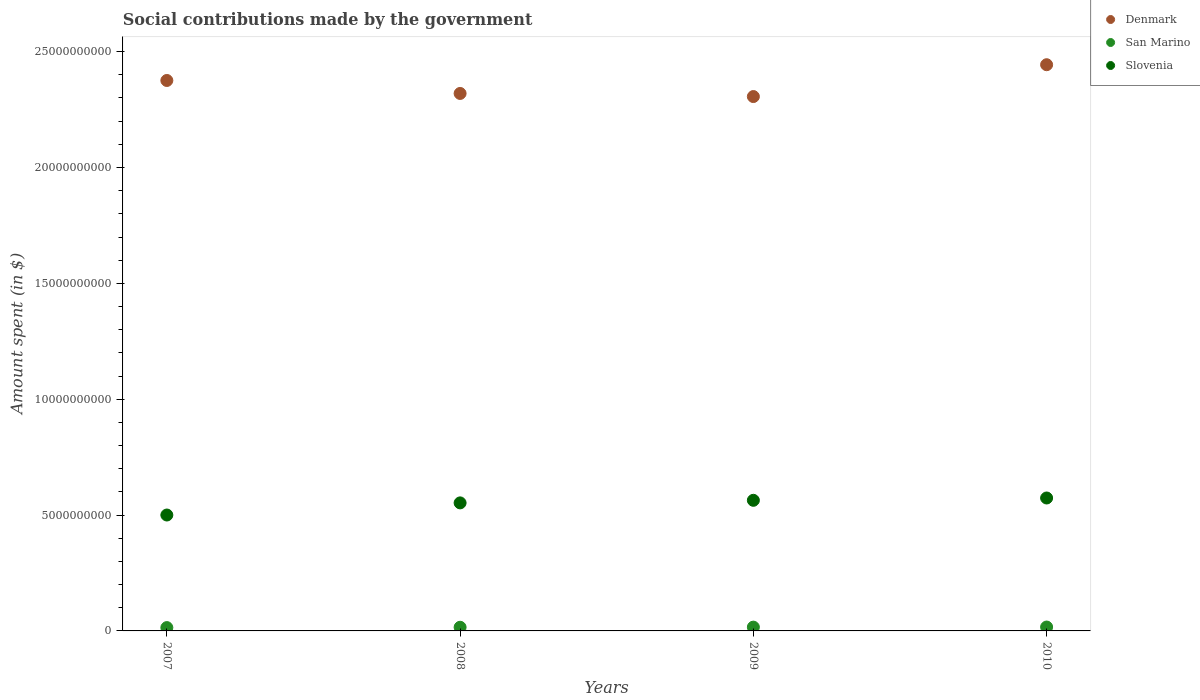What is the amount spent on social contributions in Slovenia in 2007?
Provide a succinct answer. 5.00e+09. Across all years, what is the maximum amount spent on social contributions in Denmark?
Give a very brief answer. 2.44e+1. Across all years, what is the minimum amount spent on social contributions in Slovenia?
Ensure brevity in your answer.  5.00e+09. In which year was the amount spent on social contributions in Denmark maximum?
Keep it short and to the point. 2010. In which year was the amount spent on social contributions in San Marino minimum?
Your response must be concise. 2007. What is the total amount spent on social contributions in Slovenia in the graph?
Give a very brief answer. 2.19e+1. What is the difference between the amount spent on social contributions in Denmark in 2009 and that in 2010?
Make the answer very short. -1.37e+09. What is the difference between the amount spent on social contributions in Denmark in 2008 and the amount spent on social contributions in San Marino in 2010?
Give a very brief answer. 2.30e+1. What is the average amount spent on social contributions in Denmark per year?
Give a very brief answer. 2.36e+1. In the year 2007, what is the difference between the amount spent on social contributions in Slovenia and amount spent on social contributions in San Marino?
Offer a terse response. 4.86e+09. In how many years, is the amount spent on social contributions in Slovenia greater than 1000000000 $?
Keep it short and to the point. 4. What is the ratio of the amount spent on social contributions in Denmark in 2009 to that in 2010?
Give a very brief answer. 0.94. Is the amount spent on social contributions in San Marino in 2008 less than that in 2010?
Your answer should be compact. Yes. Is the difference between the amount spent on social contributions in Slovenia in 2007 and 2010 greater than the difference between the amount spent on social contributions in San Marino in 2007 and 2010?
Give a very brief answer. No. What is the difference between the highest and the second highest amount spent on social contributions in Denmark?
Offer a terse response. 6.80e+08. What is the difference between the highest and the lowest amount spent on social contributions in Denmark?
Give a very brief answer. 1.37e+09. In how many years, is the amount spent on social contributions in Slovenia greater than the average amount spent on social contributions in Slovenia taken over all years?
Offer a terse response. 3. Is it the case that in every year, the sum of the amount spent on social contributions in Denmark and amount spent on social contributions in Slovenia  is greater than the amount spent on social contributions in San Marino?
Offer a terse response. Yes. Is the amount spent on social contributions in San Marino strictly less than the amount spent on social contributions in Denmark over the years?
Make the answer very short. Yes. What is the difference between two consecutive major ticks on the Y-axis?
Your answer should be compact. 5.00e+09. Are the values on the major ticks of Y-axis written in scientific E-notation?
Give a very brief answer. No. Does the graph contain any zero values?
Make the answer very short. No. Does the graph contain grids?
Offer a terse response. No. Where does the legend appear in the graph?
Your response must be concise. Top right. How many legend labels are there?
Offer a very short reply. 3. What is the title of the graph?
Offer a very short reply. Social contributions made by the government. Does "Denmark" appear as one of the legend labels in the graph?
Offer a terse response. Yes. What is the label or title of the Y-axis?
Your answer should be compact. Amount spent (in $). What is the Amount spent (in $) of Denmark in 2007?
Give a very brief answer. 2.38e+1. What is the Amount spent (in $) of San Marino in 2007?
Give a very brief answer. 1.44e+08. What is the Amount spent (in $) of Slovenia in 2007?
Ensure brevity in your answer.  5.00e+09. What is the Amount spent (in $) of Denmark in 2008?
Your answer should be compact. 2.32e+1. What is the Amount spent (in $) of San Marino in 2008?
Keep it short and to the point. 1.58e+08. What is the Amount spent (in $) of Slovenia in 2008?
Keep it short and to the point. 5.53e+09. What is the Amount spent (in $) in Denmark in 2009?
Give a very brief answer. 2.31e+1. What is the Amount spent (in $) in San Marino in 2009?
Provide a short and direct response. 1.64e+08. What is the Amount spent (in $) in Slovenia in 2009?
Offer a terse response. 5.64e+09. What is the Amount spent (in $) of Denmark in 2010?
Offer a terse response. 2.44e+1. What is the Amount spent (in $) of San Marino in 2010?
Offer a very short reply. 1.68e+08. What is the Amount spent (in $) of Slovenia in 2010?
Make the answer very short. 5.74e+09. Across all years, what is the maximum Amount spent (in $) of Denmark?
Your answer should be compact. 2.44e+1. Across all years, what is the maximum Amount spent (in $) of San Marino?
Your response must be concise. 1.68e+08. Across all years, what is the maximum Amount spent (in $) in Slovenia?
Your response must be concise. 5.74e+09. Across all years, what is the minimum Amount spent (in $) in Denmark?
Provide a short and direct response. 2.31e+1. Across all years, what is the minimum Amount spent (in $) in San Marino?
Your answer should be very brief. 1.44e+08. Across all years, what is the minimum Amount spent (in $) in Slovenia?
Offer a terse response. 5.00e+09. What is the total Amount spent (in $) of Denmark in the graph?
Offer a very short reply. 9.44e+1. What is the total Amount spent (in $) of San Marino in the graph?
Ensure brevity in your answer.  6.33e+08. What is the total Amount spent (in $) of Slovenia in the graph?
Provide a short and direct response. 2.19e+1. What is the difference between the Amount spent (in $) of Denmark in 2007 and that in 2008?
Provide a short and direct response. 5.60e+08. What is the difference between the Amount spent (in $) in San Marino in 2007 and that in 2008?
Provide a short and direct response. -1.39e+07. What is the difference between the Amount spent (in $) of Slovenia in 2007 and that in 2008?
Ensure brevity in your answer.  -5.23e+08. What is the difference between the Amount spent (in $) of Denmark in 2007 and that in 2009?
Give a very brief answer. 6.94e+08. What is the difference between the Amount spent (in $) in San Marino in 2007 and that in 2009?
Offer a terse response. -2.00e+07. What is the difference between the Amount spent (in $) in Slovenia in 2007 and that in 2009?
Give a very brief answer. -6.35e+08. What is the difference between the Amount spent (in $) of Denmark in 2007 and that in 2010?
Give a very brief answer. -6.80e+08. What is the difference between the Amount spent (in $) in San Marino in 2007 and that in 2010?
Provide a succinct answer. -2.40e+07. What is the difference between the Amount spent (in $) of Slovenia in 2007 and that in 2010?
Your answer should be very brief. -7.35e+08. What is the difference between the Amount spent (in $) in Denmark in 2008 and that in 2009?
Offer a terse response. 1.34e+08. What is the difference between the Amount spent (in $) in San Marino in 2008 and that in 2009?
Give a very brief answer. -6.16e+06. What is the difference between the Amount spent (in $) of Slovenia in 2008 and that in 2009?
Offer a very short reply. -1.11e+08. What is the difference between the Amount spent (in $) of Denmark in 2008 and that in 2010?
Give a very brief answer. -1.24e+09. What is the difference between the Amount spent (in $) of San Marino in 2008 and that in 2010?
Ensure brevity in your answer.  -1.01e+07. What is the difference between the Amount spent (in $) in Slovenia in 2008 and that in 2010?
Offer a terse response. -2.11e+08. What is the difference between the Amount spent (in $) of Denmark in 2009 and that in 2010?
Make the answer very short. -1.37e+09. What is the difference between the Amount spent (in $) of San Marino in 2009 and that in 2010?
Your response must be concise. -3.95e+06. What is the difference between the Amount spent (in $) of Slovenia in 2009 and that in 2010?
Offer a terse response. -9.99e+07. What is the difference between the Amount spent (in $) in Denmark in 2007 and the Amount spent (in $) in San Marino in 2008?
Provide a short and direct response. 2.36e+1. What is the difference between the Amount spent (in $) of Denmark in 2007 and the Amount spent (in $) of Slovenia in 2008?
Provide a short and direct response. 1.82e+1. What is the difference between the Amount spent (in $) of San Marino in 2007 and the Amount spent (in $) of Slovenia in 2008?
Your response must be concise. -5.38e+09. What is the difference between the Amount spent (in $) in Denmark in 2007 and the Amount spent (in $) in San Marino in 2009?
Your answer should be very brief. 2.36e+1. What is the difference between the Amount spent (in $) of Denmark in 2007 and the Amount spent (in $) of Slovenia in 2009?
Provide a short and direct response. 1.81e+1. What is the difference between the Amount spent (in $) in San Marino in 2007 and the Amount spent (in $) in Slovenia in 2009?
Offer a very short reply. -5.49e+09. What is the difference between the Amount spent (in $) in Denmark in 2007 and the Amount spent (in $) in San Marino in 2010?
Offer a very short reply. 2.36e+1. What is the difference between the Amount spent (in $) in Denmark in 2007 and the Amount spent (in $) in Slovenia in 2010?
Your answer should be very brief. 1.80e+1. What is the difference between the Amount spent (in $) of San Marino in 2007 and the Amount spent (in $) of Slovenia in 2010?
Ensure brevity in your answer.  -5.59e+09. What is the difference between the Amount spent (in $) in Denmark in 2008 and the Amount spent (in $) in San Marino in 2009?
Ensure brevity in your answer.  2.30e+1. What is the difference between the Amount spent (in $) in Denmark in 2008 and the Amount spent (in $) in Slovenia in 2009?
Make the answer very short. 1.76e+1. What is the difference between the Amount spent (in $) in San Marino in 2008 and the Amount spent (in $) in Slovenia in 2009?
Keep it short and to the point. -5.48e+09. What is the difference between the Amount spent (in $) of Denmark in 2008 and the Amount spent (in $) of San Marino in 2010?
Ensure brevity in your answer.  2.30e+1. What is the difference between the Amount spent (in $) in Denmark in 2008 and the Amount spent (in $) in Slovenia in 2010?
Offer a terse response. 1.75e+1. What is the difference between the Amount spent (in $) of San Marino in 2008 and the Amount spent (in $) of Slovenia in 2010?
Offer a very short reply. -5.58e+09. What is the difference between the Amount spent (in $) in Denmark in 2009 and the Amount spent (in $) in San Marino in 2010?
Your answer should be very brief. 2.29e+1. What is the difference between the Amount spent (in $) of Denmark in 2009 and the Amount spent (in $) of Slovenia in 2010?
Keep it short and to the point. 1.73e+1. What is the difference between the Amount spent (in $) in San Marino in 2009 and the Amount spent (in $) in Slovenia in 2010?
Your answer should be compact. -5.57e+09. What is the average Amount spent (in $) of Denmark per year?
Provide a succinct answer. 2.36e+1. What is the average Amount spent (in $) of San Marino per year?
Give a very brief answer. 1.58e+08. What is the average Amount spent (in $) in Slovenia per year?
Give a very brief answer. 5.48e+09. In the year 2007, what is the difference between the Amount spent (in $) in Denmark and Amount spent (in $) in San Marino?
Your response must be concise. 2.36e+1. In the year 2007, what is the difference between the Amount spent (in $) in Denmark and Amount spent (in $) in Slovenia?
Your answer should be very brief. 1.88e+1. In the year 2007, what is the difference between the Amount spent (in $) in San Marino and Amount spent (in $) in Slovenia?
Your answer should be very brief. -4.86e+09. In the year 2008, what is the difference between the Amount spent (in $) in Denmark and Amount spent (in $) in San Marino?
Keep it short and to the point. 2.30e+1. In the year 2008, what is the difference between the Amount spent (in $) of Denmark and Amount spent (in $) of Slovenia?
Offer a very short reply. 1.77e+1. In the year 2008, what is the difference between the Amount spent (in $) of San Marino and Amount spent (in $) of Slovenia?
Provide a succinct answer. -5.37e+09. In the year 2009, what is the difference between the Amount spent (in $) in Denmark and Amount spent (in $) in San Marino?
Ensure brevity in your answer.  2.29e+1. In the year 2009, what is the difference between the Amount spent (in $) of Denmark and Amount spent (in $) of Slovenia?
Your response must be concise. 1.74e+1. In the year 2009, what is the difference between the Amount spent (in $) in San Marino and Amount spent (in $) in Slovenia?
Make the answer very short. -5.47e+09. In the year 2010, what is the difference between the Amount spent (in $) in Denmark and Amount spent (in $) in San Marino?
Your answer should be very brief. 2.43e+1. In the year 2010, what is the difference between the Amount spent (in $) in Denmark and Amount spent (in $) in Slovenia?
Your answer should be compact. 1.87e+1. In the year 2010, what is the difference between the Amount spent (in $) of San Marino and Amount spent (in $) of Slovenia?
Ensure brevity in your answer.  -5.57e+09. What is the ratio of the Amount spent (in $) of Denmark in 2007 to that in 2008?
Give a very brief answer. 1.02. What is the ratio of the Amount spent (in $) in San Marino in 2007 to that in 2008?
Your response must be concise. 0.91. What is the ratio of the Amount spent (in $) in Slovenia in 2007 to that in 2008?
Your answer should be very brief. 0.91. What is the ratio of the Amount spent (in $) of Denmark in 2007 to that in 2009?
Offer a terse response. 1.03. What is the ratio of the Amount spent (in $) of San Marino in 2007 to that in 2009?
Offer a very short reply. 0.88. What is the ratio of the Amount spent (in $) of Slovenia in 2007 to that in 2009?
Give a very brief answer. 0.89. What is the ratio of the Amount spent (in $) in Denmark in 2007 to that in 2010?
Your response must be concise. 0.97. What is the ratio of the Amount spent (in $) of San Marino in 2007 to that in 2010?
Your answer should be very brief. 0.86. What is the ratio of the Amount spent (in $) of Slovenia in 2007 to that in 2010?
Provide a short and direct response. 0.87. What is the ratio of the Amount spent (in $) in Denmark in 2008 to that in 2009?
Keep it short and to the point. 1.01. What is the ratio of the Amount spent (in $) in San Marino in 2008 to that in 2009?
Your answer should be very brief. 0.96. What is the ratio of the Amount spent (in $) of Slovenia in 2008 to that in 2009?
Keep it short and to the point. 0.98. What is the ratio of the Amount spent (in $) of Denmark in 2008 to that in 2010?
Give a very brief answer. 0.95. What is the ratio of the Amount spent (in $) in San Marino in 2008 to that in 2010?
Offer a terse response. 0.94. What is the ratio of the Amount spent (in $) of Slovenia in 2008 to that in 2010?
Your answer should be compact. 0.96. What is the ratio of the Amount spent (in $) in Denmark in 2009 to that in 2010?
Offer a very short reply. 0.94. What is the ratio of the Amount spent (in $) in San Marino in 2009 to that in 2010?
Keep it short and to the point. 0.98. What is the ratio of the Amount spent (in $) in Slovenia in 2009 to that in 2010?
Make the answer very short. 0.98. What is the difference between the highest and the second highest Amount spent (in $) of Denmark?
Provide a succinct answer. 6.80e+08. What is the difference between the highest and the second highest Amount spent (in $) in San Marino?
Make the answer very short. 3.95e+06. What is the difference between the highest and the second highest Amount spent (in $) in Slovenia?
Provide a short and direct response. 9.99e+07. What is the difference between the highest and the lowest Amount spent (in $) of Denmark?
Give a very brief answer. 1.37e+09. What is the difference between the highest and the lowest Amount spent (in $) in San Marino?
Keep it short and to the point. 2.40e+07. What is the difference between the highest and the lowest Amount spent (in $) of Slovenia?
Give a very brief answer. 7.35e+08. 